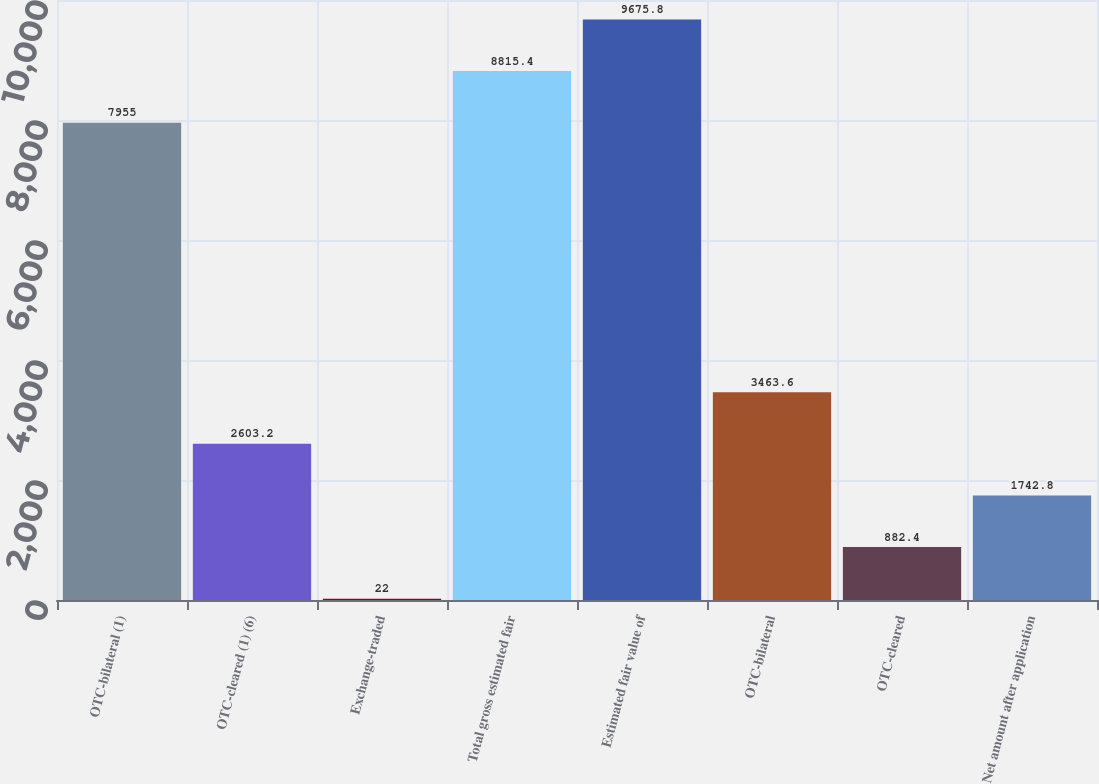Convert chart. <chart><loc_0><loc_0><loc_500><loc_500><bar_chart><fcel>OTC-bilateral (1)<fcel>OTC-cleared (1) (6)<fcel>Exchange-traded<fcel>Total gross estimated fair<fcel>Estimated fair value of<fcel>OTC-bilateral<fcel>OTC-cleared<fcel>Net amount after application<nl><fcel>7955<fcel>2603.2<fcel>22<fcel>8815.4<fcel>9675.8<fcel>3463.6<fcel>882.4<fcel>1742.8<nl></chart> 